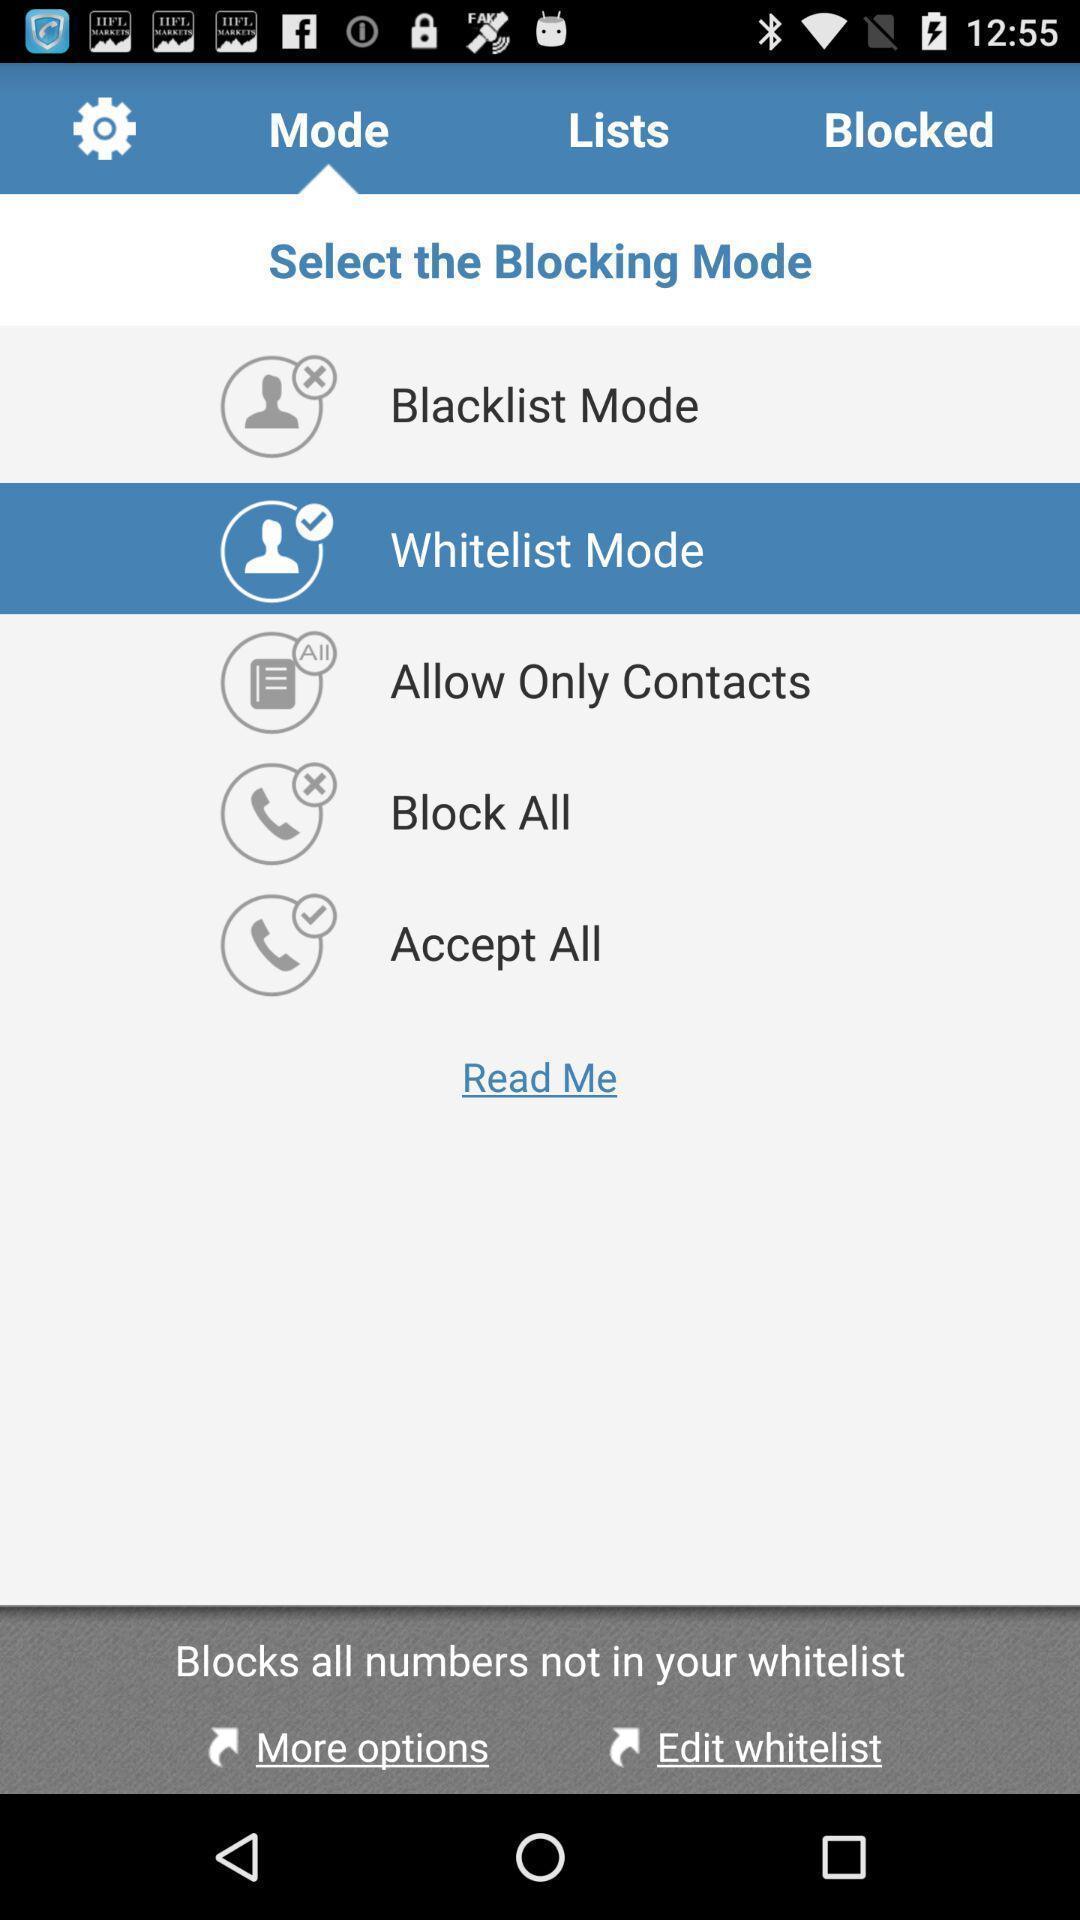Provide a description of this screenshot. Page for contact app with various options. 